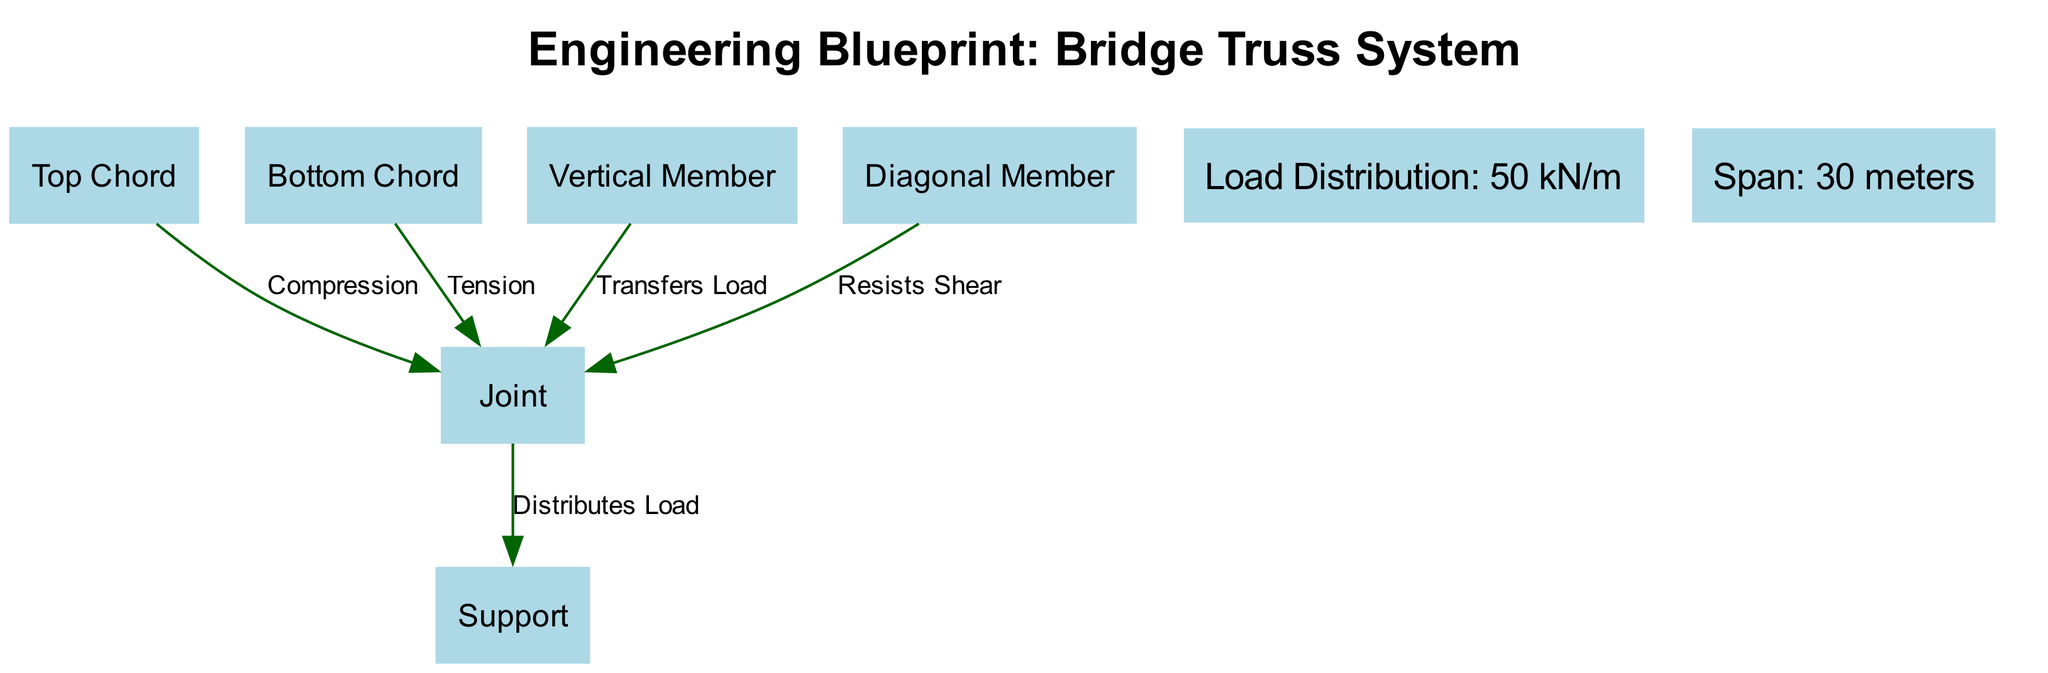What is the label of node 1? Node 1 is labeled "Top Chord," as indicated in the nodes section of the data provided.
Answer: Top Chord How many edges are there in the diagram? The diagram contains five edges, as listed in the edges section of the data.
Answer: 5 What type of load does the bottom chord experience? The edge connecting the Bottom Chord (node 2) to the Joint (node 5) is labeled as "Tension," indicating the type of load experienced.
Answer: Tension What is the load distribution value illustrated in the diagram? The annotation at the top of the diagram indicates that the load distribution is "50 kN/m."
Answer: 50 kN/m Which member is responsible for resisting shear? The edge from the Diagonal Member (node 4) to the Joint (node 5) is labeled "Resists Shear," indicating its function.
Answer: Diagonal Member What is the span of the bridge as indicated in the diagram? The annotation at the bottom of the diagram reveals that the span measured is "30 meters."
Answer: 30 meters How does the vertical member function in the bridge design? The edge from the Vertical Member (node 3) to the Joint (node 5) is labeled "Transfers Load," indicating its role in load distribution.
Answer: Transfers Load Which nodes are connected to the Joint? The Joint (node 5) connects to the Top Chord, Bottom Chord, Vertical Member, and Diagonal Member, meaning 4 nodes are linked to it.
Answer: 4 nodes How is the load distributed from the joint to the support? The edge from the Joint (node 5) to the Support (node 6) is labeled "Distributes Load," showing how load is transferred to this structural element.
Answer: Distributes Load 